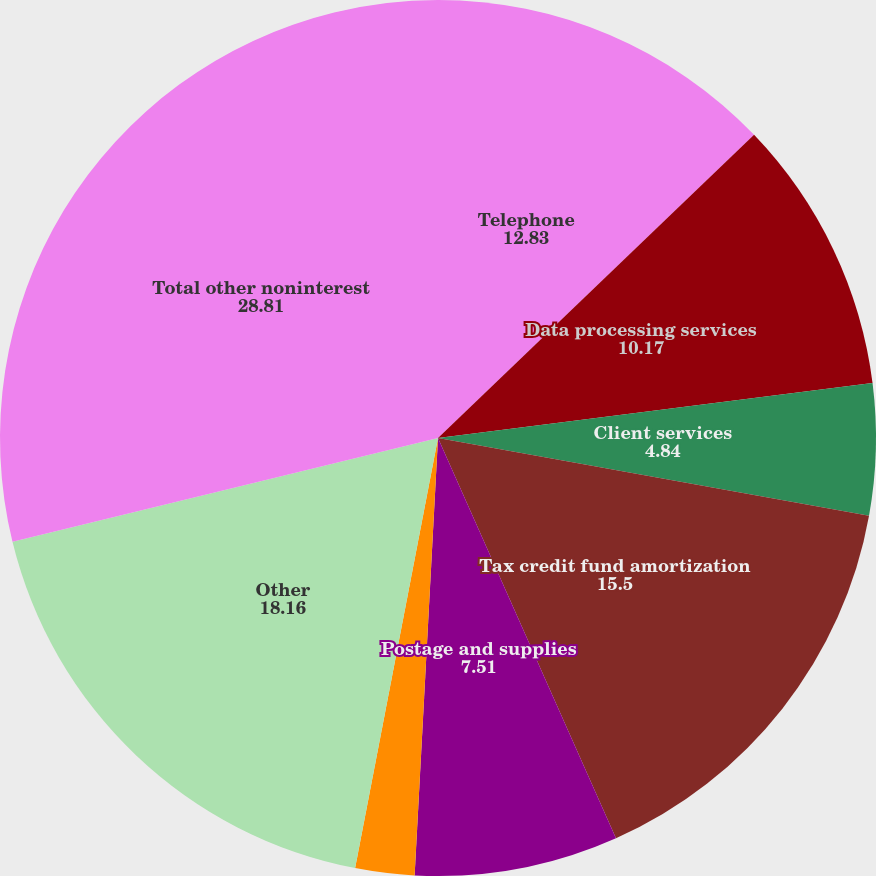<chart> <loc_0><loc_0><loc_500><loc_500><pie_chart><fcel>Telephone<fcel>Data processing services<fcel>Client services<fcel>Tax credit fund amortization<fcel>Postage and supplies<fcel>Dues and publications<fcel>Other<fcel>Total other noninterest<nl><fcel>12.83%<fcel>10.17%<fcel>4.84%<fcel>15.5%<fcel>7.51%<fcel>2.18%<fcel>18.16%<fcel>28.81%<nl></chart> 